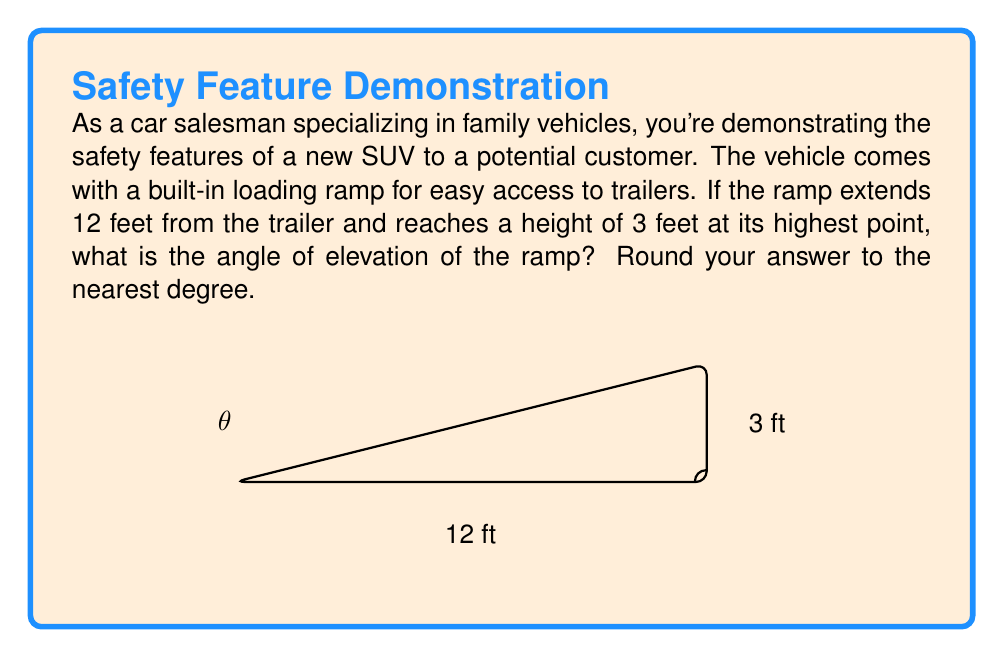Can you answer this question? To solve this problem, we'll use trigonometry. Let's break it down step-by-step:

1) We have a right triangle where:
   - The base (adjacent side) is 12 feet
   - The height (opposite side) is 3 feet
   - We need to find the angle $\theta$ at the base of the ramp

2) In a right triangle, the tangent of an angle is the ratio of the opposite side to the adjacent side:

   $$\tan(\theta) = \frac{\text{opposite}}{\text{adjacent}} = \frac{\text{height}}{\text{base}}$$

3) Plugging in our values:

   $$\tan(\theta) = \frac{3}{12} = \frac{1}{4} = 0.25$$

4) To find $\theta$, we need to use the inverse tangent (arctan or $\tan^{-1}$):

   $$\theta = \tan^{-1}(0.25)$$

5) Using a calculator or trigonometric tables:

   $$\theta \approx 14.0362^\circ$$

6) Rounding to the nearest degree:

   $$\theta \approx 14^\circ$$

This angle is safe for most vehicles, as it's not too steep, making it easier and safer to load the vehicle onto the trailer.
Answer: $14^\circ$ 